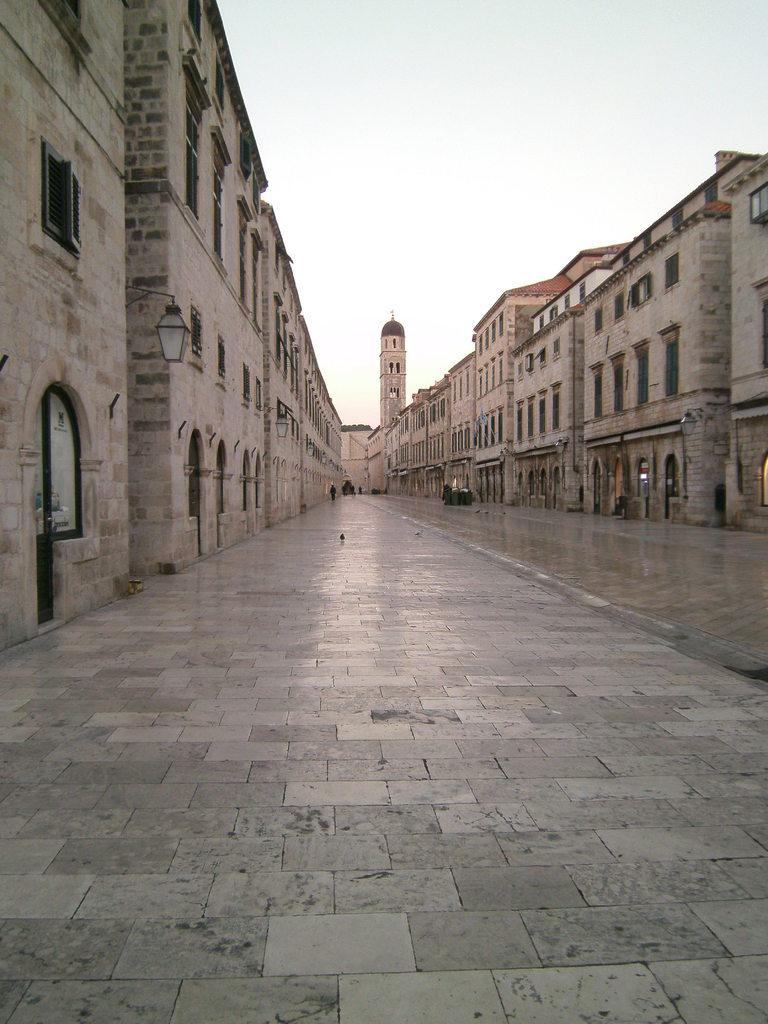What type of structures are located on both sides of the image? There are buildings on both sides of the image. What feature can be seen on the buildings in the image? There are windows visible in the image. What type of surface is at the bottom of the image? There is pavement at the bottom of the image. What is visible at the top of the image? The sky is visible at the top of the image. What type of linen is draped over the buildings in the image? There is no linen draped over the buildings in the image; the buildings are simply standing with windows visible. 